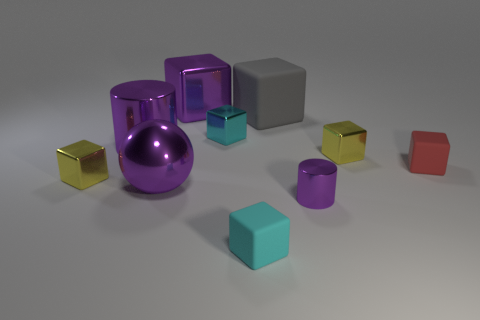Are there any other things that are the same size as the cyan shiny cube?
Make the answer very short. Yes. The sphere that is the same color as the large metal cylinder is what size?
Offer a terse response. Large. Does the yellow thing on the left side of the large purple cylinder have the same size as the matte cube that is in front of the small red cube?
Provide a succinct answer. Yes. There is a cyan object behind the large ball; what is its size?
Keep it short and to the point. Small. Is there a large shiny cylinder that has the same color as the big shiny cube?
Your answer should be very brief. Yes. Are there any yellow metallic cubes to the right of the tiny cyan object in front of the big sphere?
Your answer should be very brief. Yes. There is a red matte thing; is it the same size as the purple cylinder that is on the left side of the small cyan matte block?
Offer a terse response. No. There is a purple shiny cylinder on the right side of the cyan block in front of the tiny cyan shiny thing; are there any tiny matte objects left of it?
Keep it short and to the point. Yes. What is the yellow cube on the left side of the big purple sphere made of?
Give a very brief answer. Metal. Is the purple cube the same size as the cyan rubber thing?
Provide a short and direct response. No. 